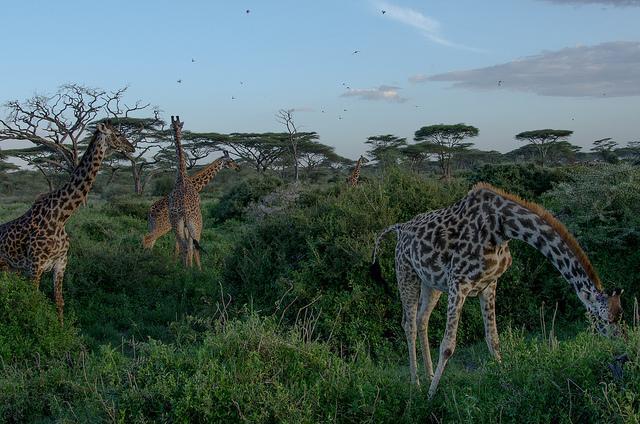How many giraffes can clearly be seen grazing in the area?
Indicate the correct response and explain using: 'Answer: answer
Rationale: rationale.'
Options: Five, six, four, seven. Answer: five.
Rationale: That's how many giraffes are in the picture. 